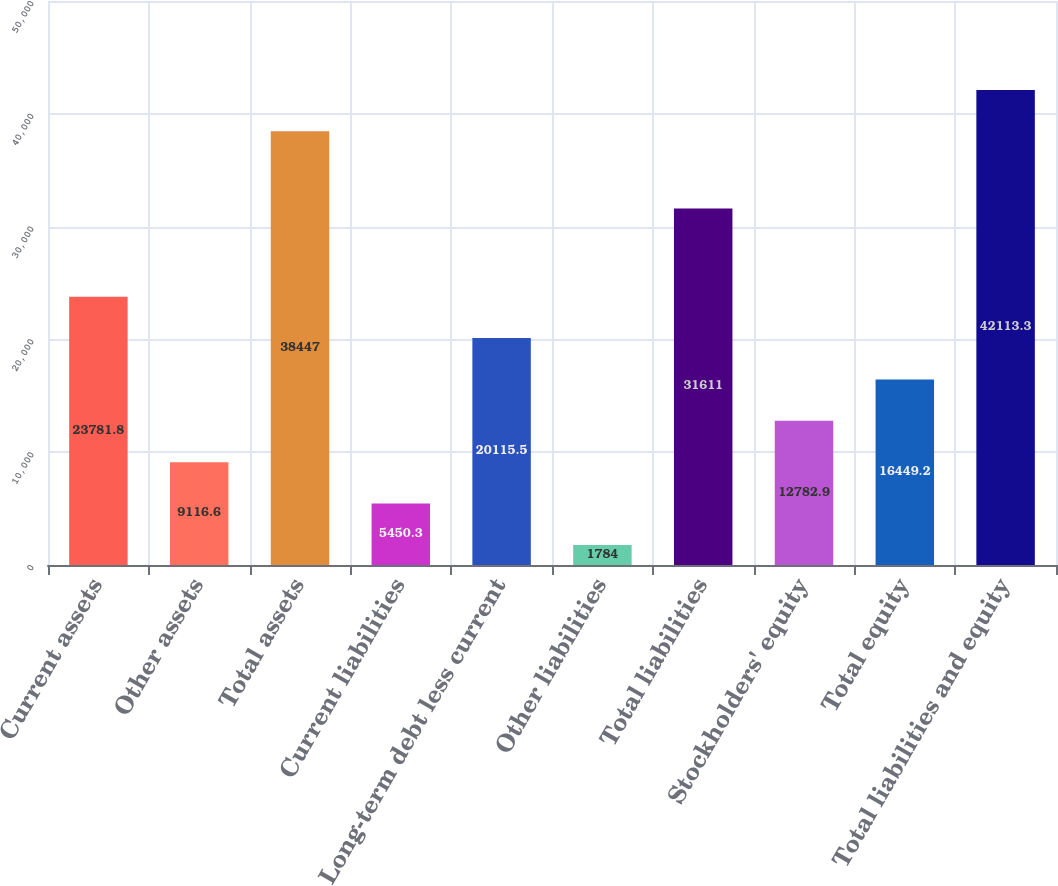Convert chart to OTSL. <chart><loc_0><loc_0><loc_500><loc_500><bar_chart><fcel>Current assets<fcel>Other assets<fcel>Total assets<fcel>Current liabilities<fcel>Long-term debt less current<fcel>Other liabilities<fcel>Total liabilities<fcel>Stockholders' equity<fcel>Total equity<fcel>Total liabilities and equity<nl><fcel>23781.8<fcel>9116.6<fcel>38447<fcel>5450.3<fcel>20115.5<fcel>1784<fcel>31611<fcel>12782.9<fcel>16449.2<fcel>42113.3<nl></chart> 